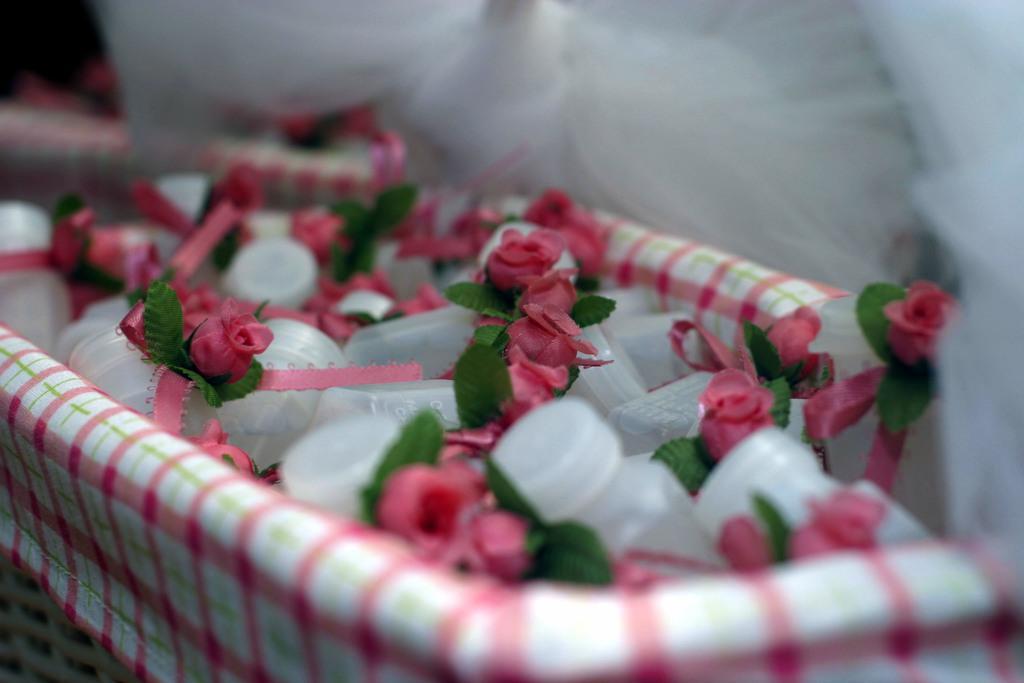How would you summarize this image in a sentence or two? In this image I can see few flowers in pink color and I can also see few bottles in the basket and the basket is in white and pink color. 